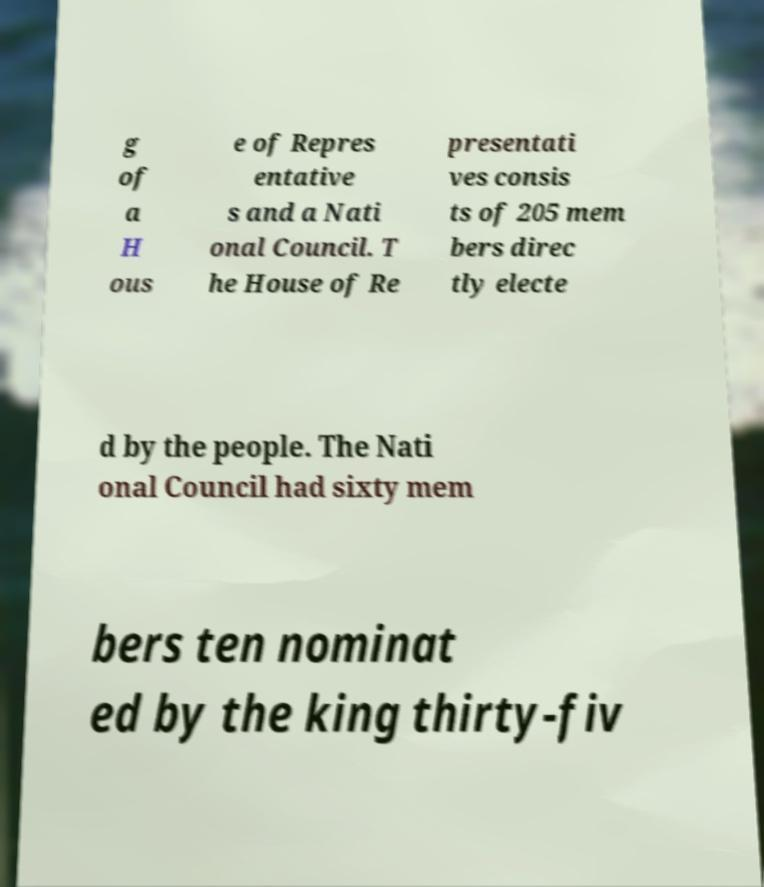Please read and relay the text visible in this image. What does it say? g of a H ous e of Repres entative s and a Nati onal Council. T he House of Re presentati ves consis ts of 205 mem bers direc tly electe d by the people. The Nati onal Council had sixty mem bers ten nominat ed by the king thirty-fiv 